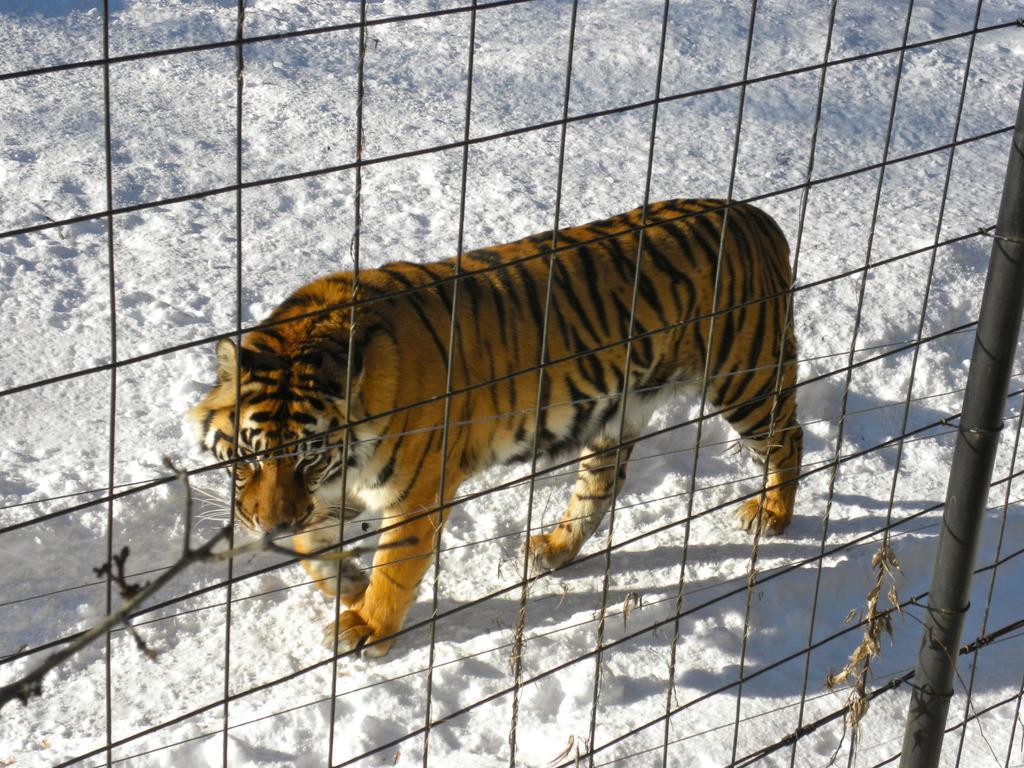How would you summarize this image in a sentence or two? In this image we can see a Tiger which is in Fence. And we can see snow in the background and bottom. And some branches of the tree and poles are seen in the foreground. 